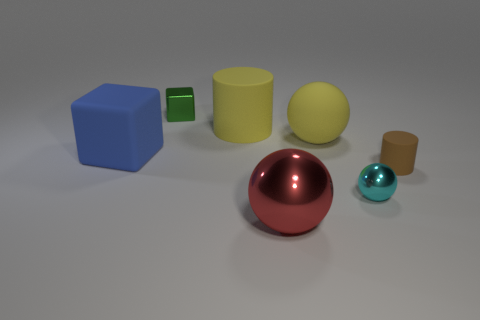Subtract all yellow rubber spheres. How many spheres are left? 2 Subtract all yellow cylinders. How many cylinders are left? 1 Add 2 cyan balls. How many objects exist? 9 Subtract all cylinders. How many objects are left? 5 Subtract 2 blocks. How many blocks are left? 0 Add 1 metal balls. How many metal balls are left? 3 Add 6 blue objects. How many blue objects exist? 7 Subtract 0 cyan blocks. How many objects are left? 7 Subtract all green cylinders. Subtract all red cubes. How many cylinders are left? 2 Subtract all gray cylinders. How many green cubes are left? 1 